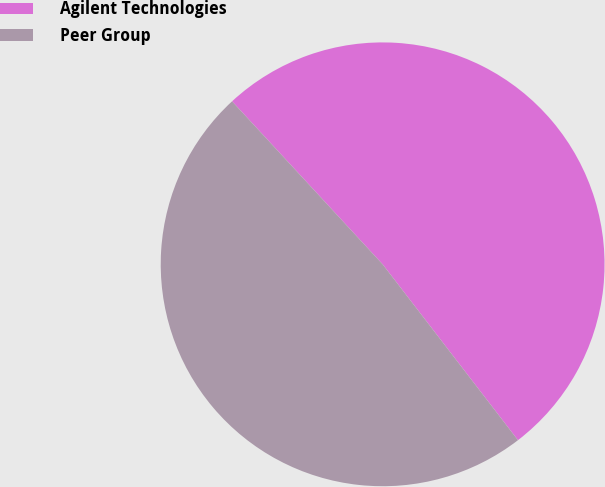<chart> <loc_0><loc_0><loc_500><loc_500><pie_chart><fcel>Agilent Technologies<fcel>Peer Group<nl><fcel>51.43%<fcel>48.57%<nl></chart> 